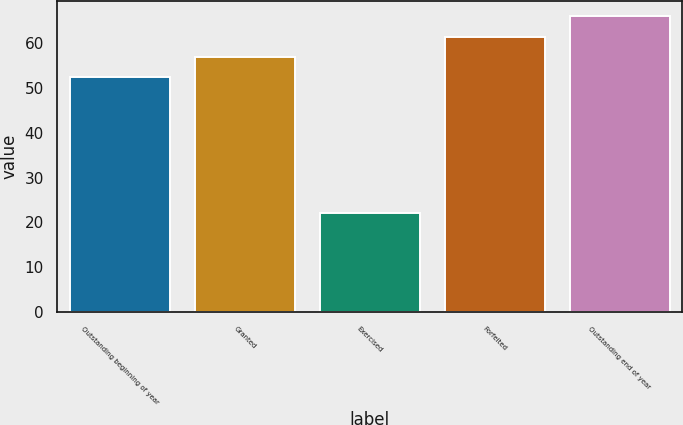Convert chart to OTSL. <chart><loc_0><loc_0><loc_500><loc_500><bar_chart><fcel>Outstanding beginning of year<fcel>Granted<fcel>Exercised<fcel>Forfeited<fcel>Outstanding end of year<nl><fcel>52.49<fcel>56.9<fcel>22.02<fcel>61.31<fcel>66.08<nl></chart> 